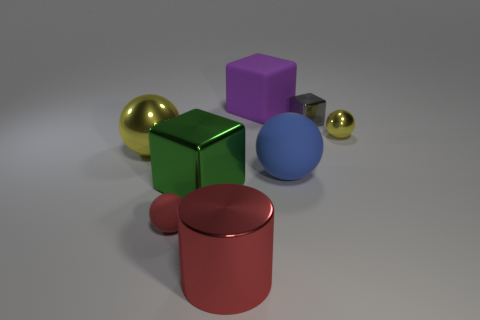The large thing that is in front of the rubber object that is to the left of the green block is what color?
Offer a very short reply. Red. There is a gray thing that is the same shape as the big green object; what is it made of?
Your answer should be compact. Metal. What number of metal objects are things or red balls?
Your answer should be very brief. 5. Are the yellow thing that is to the left of the big purple rubber cube and the small thing that is in front of the blue matte sphere made of the same material?
Make the answer very short. No. Is there a tiny yellow metallic sphere?
Provide a succinct answer. Yes. Do the object on the right side of the small cube and the tiny object to the left of the large shiny cylinder have the same shape?
Your response must be concise. Yes. Is there a small cyan cylinder made of the same material as the purple block?
Offer a very short reply. No. Do the large object to the left of the tiny red thing and the blue object have the same material?
Offer a terse response. No. Is the number of balls that are to the right of the large green shiny block greater than the number of red metal cylinders in front of the cylinder?
Your answer should be compact. Yes. The rubber sphere that is the same size as the purple cube is what color?
Your response must be concise. Blue. 